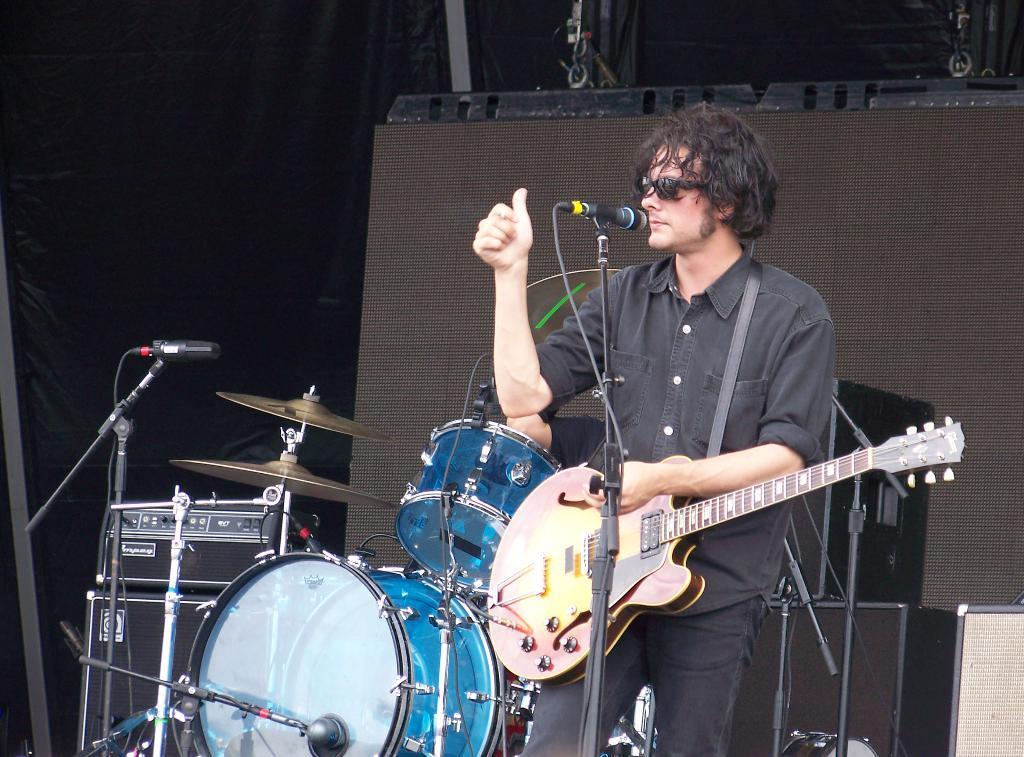Who is present in the image? There is a man in the image. What is the man wearing on his face? The man is wearing spectacles. What objects are in front of the man? There are musical instruments and microphones in front of the man. What can be seen in the background of the image? There are speakers visible in the background of the image. What type of toothpaste is the man using in the image? There is no toothpaste present in the image. What song is the man singing in the image? The image does not show the man singing, so it cannot be determined which song he might be singing. 